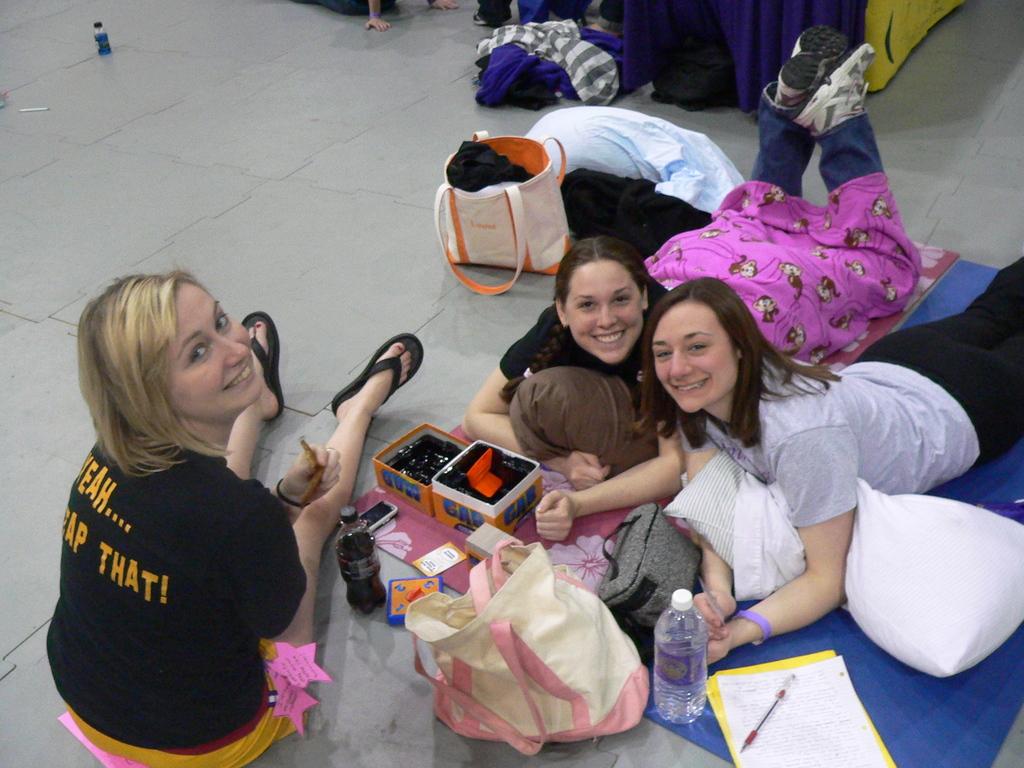What does it say across the back of her shirt?
Your answer should be compact. Yeah.... slap that!. 